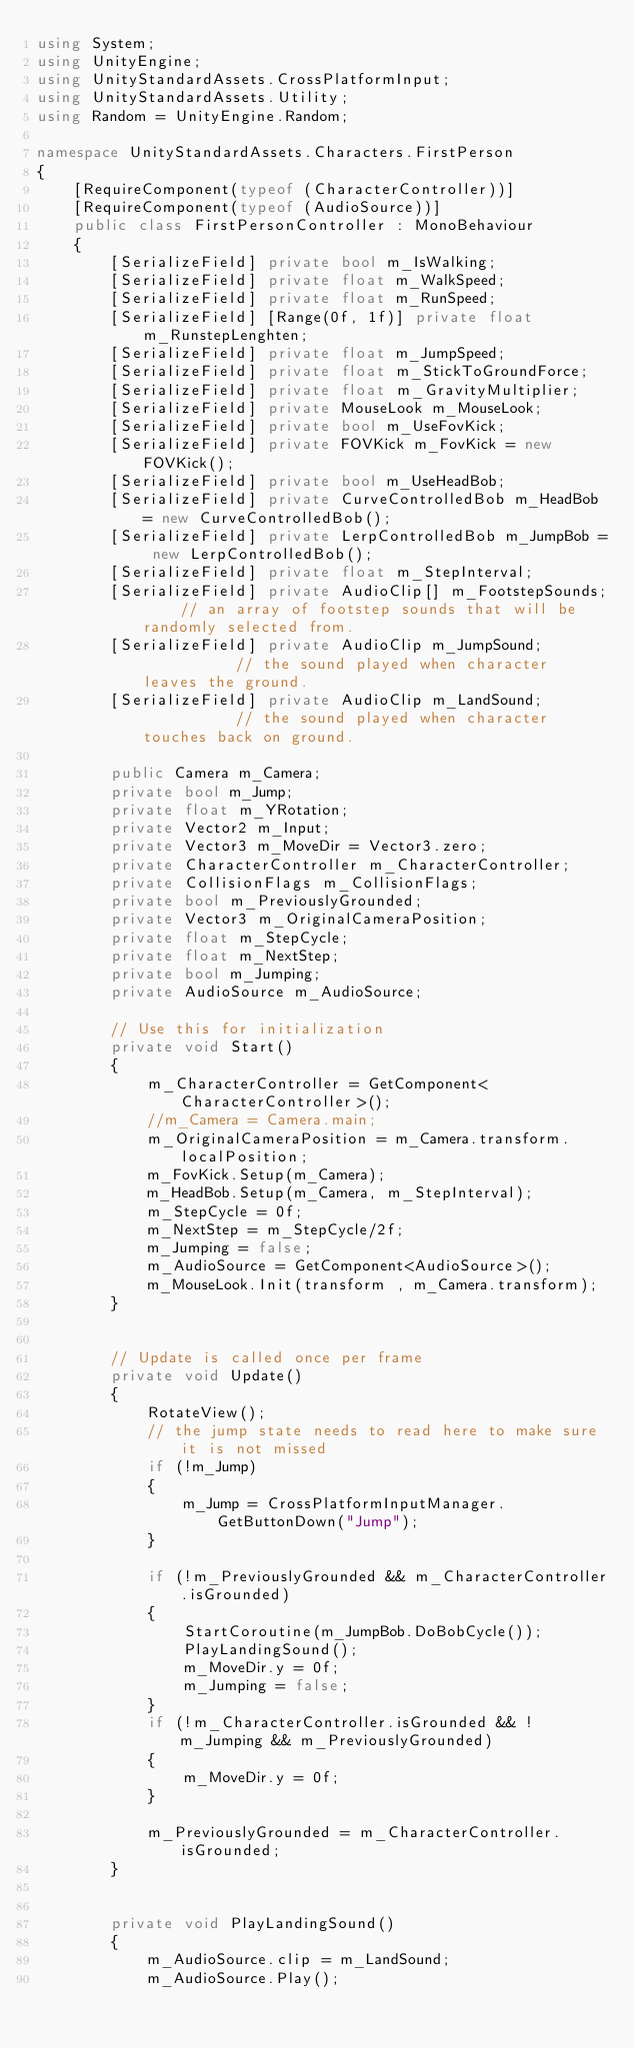Convert code to text. <code><loc_0><loc_0><loc_500><loc_500><_C#_>using System;
using UnityEngine;
using UnityStandardAssets.CrossPlatformInput;
using UnityStandardAssets.Utility;
using Random = UnityEngine.Random;

namespace UnityStandardAssets.Characters.FirstPerson
{
    [RequireComponent(typeof (CharacterController))]
    [RequireComponent(typeof (AudioSource))]
    public class FirstPersonController : MonoBehaviour
    {
        [SerializeField] private bool m_IsWalking;
        [SerializeField] private float m_WalkSpeed;
        [SerializeField] private float m_RunSpeed;
        [SerializeField] [Range(0f, 1f)] private float m_RunstepLenghten;
        [SerializeField] private float m_JumpSpeed;
        [SerializeField] private float m_StickToGroundForce;
        [SerializeField] private float m_GravityMultiplier;
        [SerializeField] private MouseLook m_MouseLook;
        [SerializeField] private bool m_UseFovKick;
        [SerializeField] private FOVKick m_FovKick = new FOVKick();
        [SerializeField] private bool m_UseHeadBob;
        [SerializeField] private CurveControlledBob m_HeadBob = new CurveControlledBob();
        [SerializeField] private LerpControlledBob m_JumpBob = new LerpControlledBob();
        [SerializeField] private float m_StepInterval;
        [SerializeField] private AudioClip[] m_FootstepSounds;    // an array of footstep sounds that will be randomly selected from.
        [SerializeField] private AudioClip m_JumpSound;           // the sound played when character leaves the ground.
        [SerializeField] private AudioClip m_LandSound;           // the sound played when character touches back on ground.

        public Camera m_Camera;
        private bool m_Jump;
        private float m_YRotation;
        private Vector2 m_Input;
        private Vector3 m_MoveDir = Vector3.zero;
        private CharacterController m_CharacterController;
        private CollisionFlags m_CollisionFlags;
        private bool m_PreviouslyGrounded;
        private Vector3 m_OriginalCameraPosition;
        private float m_StepCycle;
        private float m_NextStep;
        private bool m_Jumping;
        private AudioSource m_AudioSource;

        // Use this for initialization
        private void Start()
        {
            m_CharacterController = GetComponent<CharacterController>();
            //m_Camera = Camera.main;
            m_OriginalCameraPosition = m_Camera.transform.localPosition;
            m_FovKick.Setup(m_Camera);
            m_HeadBob.Setup(m_Camera, m_StepInterval);
            m_StepCycle = 0f;
            m_NextStep = m_StepCycle/2f;
            m_Jumping = false;
            m_AudioSource = GetComponent<AudioSource>();
			m_MouseLook.Init(transform , m_Camera.transform);
        }


        // Update is called once per frame
        private void Update()
        {
            RotateView();
            // the jump state needs to read here to make sure it is not missed
            if (!m_Jump)
            {
                m_Jump = CrossPlatformInputManager.GetButtonDown("Jump");
            }

            if (!m_PreviouslyGrounded && m_CharacterController.isGrounded)
            {
                StartCoroutine(m_JumpBob.DoBobCycle());
                PlayLandingSound();
                m_MoveDir.y = 0f;
                m_Jumping = false;
            }
            if (!m_CharacterController.isGrounded && !m_Jumping && m_PreviouslyGrounded)
            {
                m_MoveDir.y = 0f;
            }

            m_PreviouslyGrounded = m_CharacterController.isGrounded;
        }


        private void PlayLandingSound()
        {
            m_AudioSource.clip = m_LandSound;
            m_AudioSource.Play();</code> 